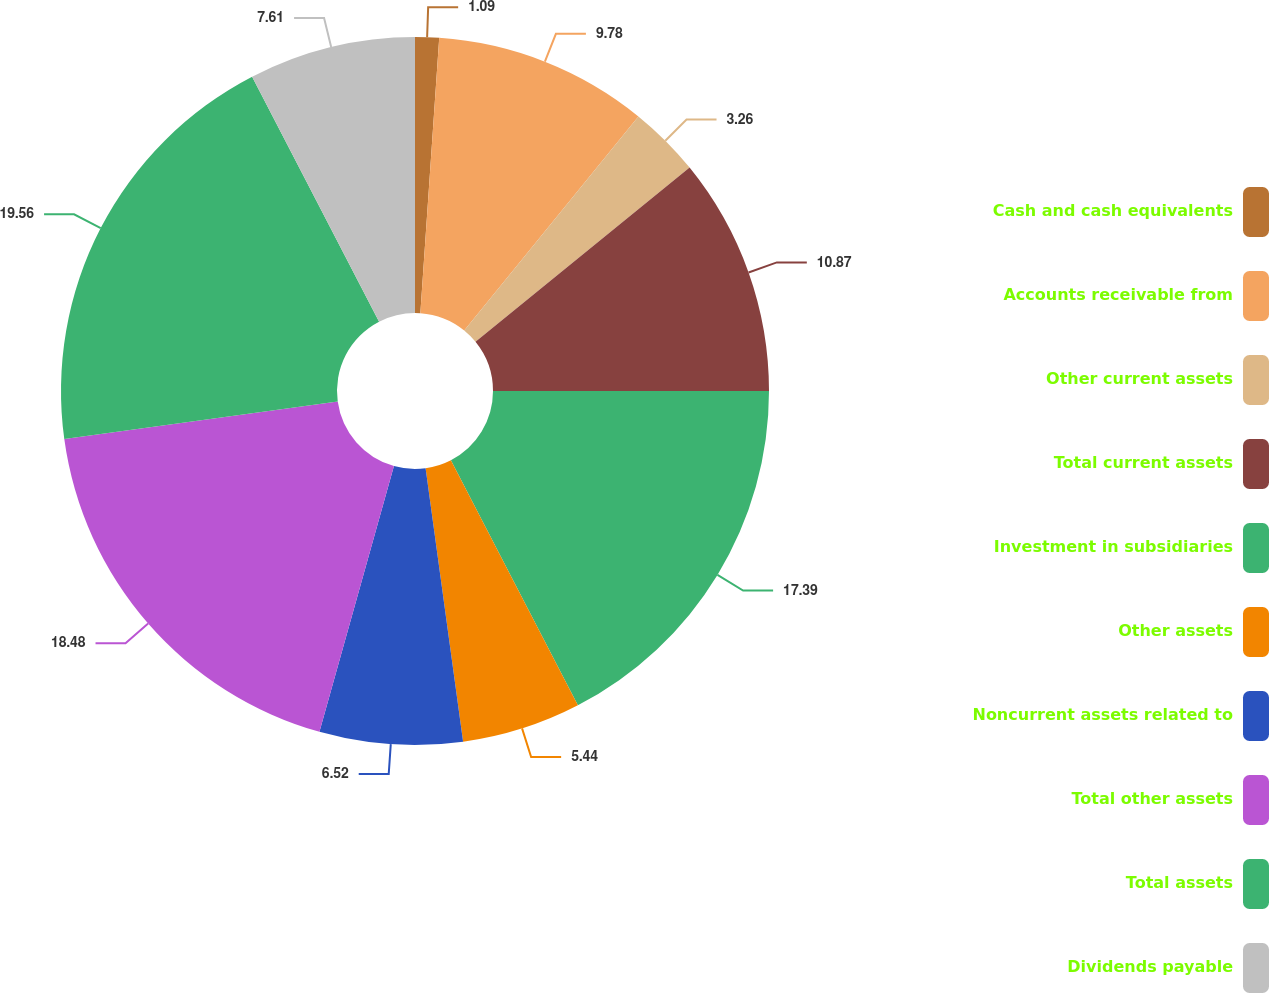Convert chart to OTSL. <chart><loc_0><loc_0><loc_500><loc_500><pie_chart><fcel>Cash and cash equivalents<fcel>Accounts receivable from<fcel>Other current assets<fcel>Total current assets<fcel>Investment in subsidiaries<fcel>Other assets<fcel>Noncurrent assets related to<fcel>Total other assets<fcel>Total assets<fcel>Dividends payable<nl><fcel>1.09%<fcel>9.78%<fcel>3.26%<fcel>10.87%<fcel>17.39%<fcel>5.44%<fcel>6.52%<fcel>18.48%<fcel>19.56%<fcel>7.61%<nl></chart> 